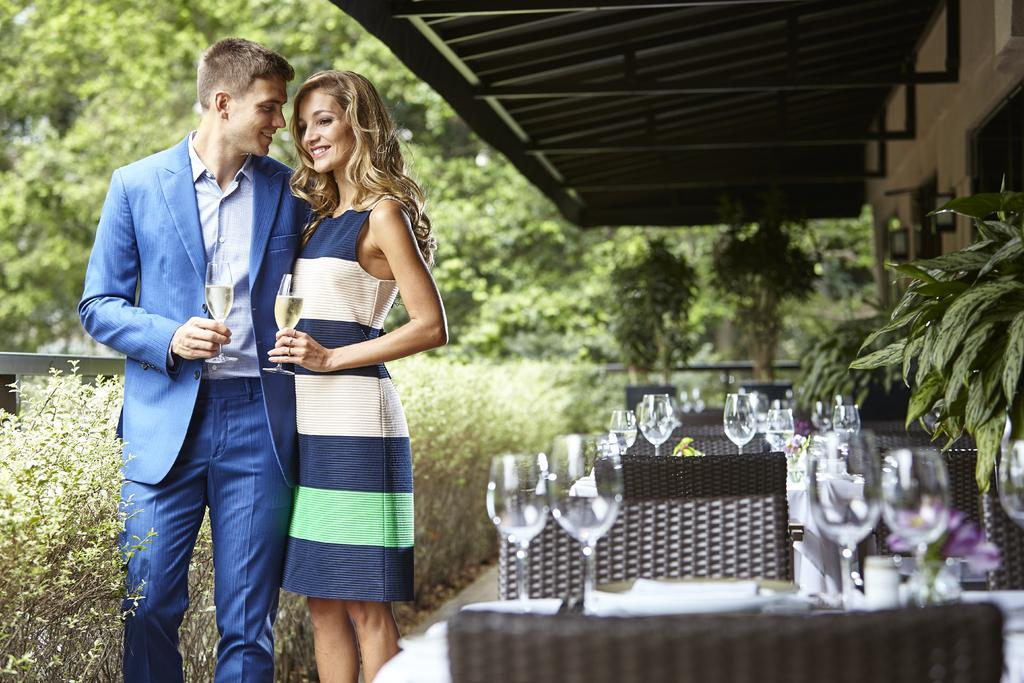How many people are in the image? There are two people standing in the image. What are the people holding in their hands? The people are holding wine glasses. What else can be seen on the table in the image? There are glasses on the table in the image. What can be seen in the distance behind the people? There are trees visible in the background of the image. What type of prose is being read by the people in the image? There is no indication in the image that the people are reading any prose, as they are holding wine glasses and there are no books or written materials visible. 